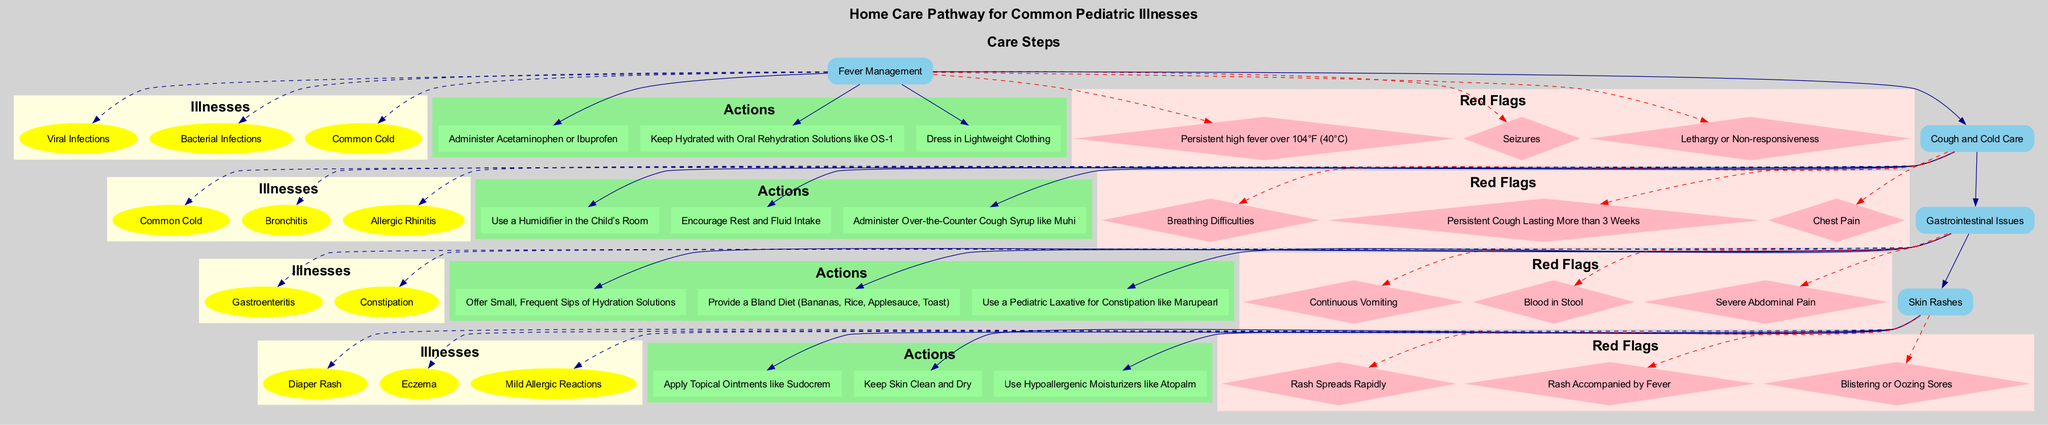What is the first step in the pathway? The diagram indicates that "Fever Management" is the first step listed in the clinical pathway.
Answer: Fever Management How many illnesses are included in cough and cold care? The diagram shows three illnesses listed under the "Cough and Cold Care" step, specifically the Common Cold, Bronchitis, and Allergic Rhinitis.
Answer: 3 What action is recommended for skin rashes? For skin rashes, the diagram advises to "Apply Topical Ointments like Sudocrem." This action is prominently outlined under the relevant care step.
Answer: Apply Topical Ointments like Sudocrem What red flag indicates severe abdominal pain? The red flag "Severe Abdominal Pain" is specifically stated under the "Gastrointestinal Issues" step, indicating a serious symptom to watch for.
Answer: Severe Abdominal Pain Which action is common in both fever management and gastrointestinal issues? Both steps suggest "Keep Hydrated" as part of their actions; however, in the fever management context, it specifies using Oral Rehydration Solutions while gastrointestinal issues emphasize hydration solutions.
Answer: Keep Hydrated What symptom would indicate a need for immediate attention in cough and cold care? "Breathing Difficulties" is a crucial red flag listed under cough and cold care that requires immediate medical attention as shown in the diagram.
Answer: Breathing Difficulties How is the relationship between actions and red flags depicted? The diagram demonstrates that red flags like "Persistent Cough Lasting More than 3 Weeks" are connected to the "Cough and Cold Care" step, highlighting importance in monitoring actions alongside symptoms.
Answer: Connected What is the last step in the clinical pathway? The final step depicted in the pathway is "Skin Rashes," which includes its respective illnesses, actions, and red flags about proper care for this condition.
Answer: Skin Rashes Which illness is solely addressed in gastrointestinal issues? "Constipation" exclusively pertains to the "Gastrointestinal Issues" step, indicating that it does not overlap with any other steps.
Answer: Constipation 